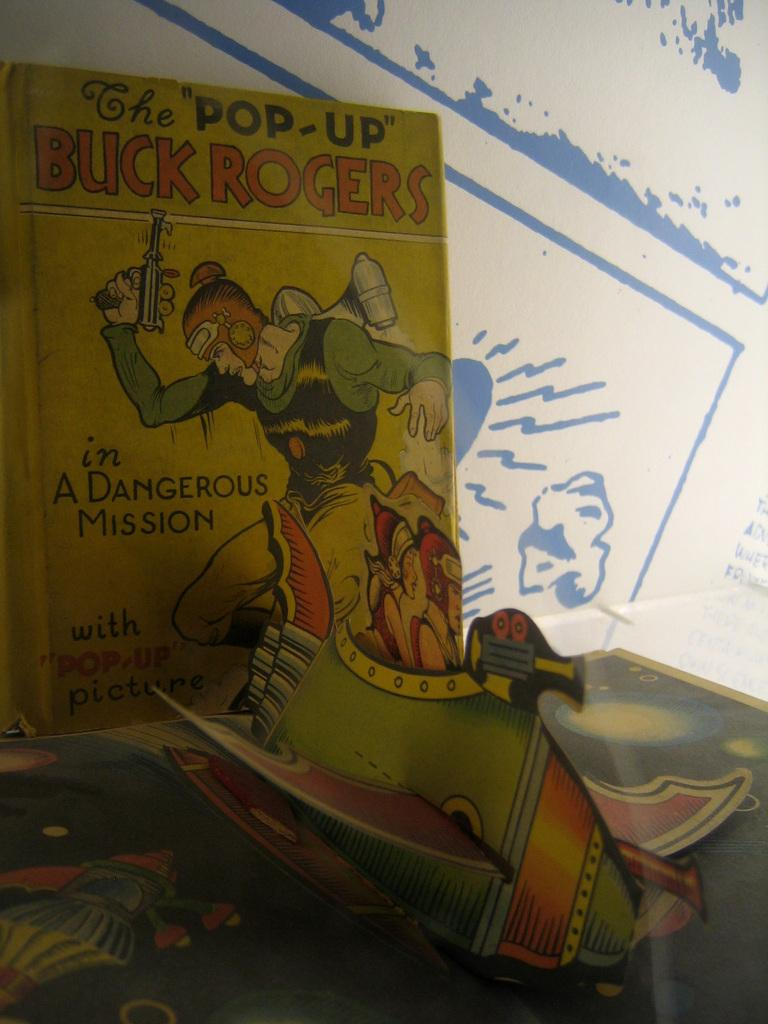Provide a one-sentence caption for the provided image. The Pop-Up Buck Rogers book shows a man wearing a helmet on the cover. 